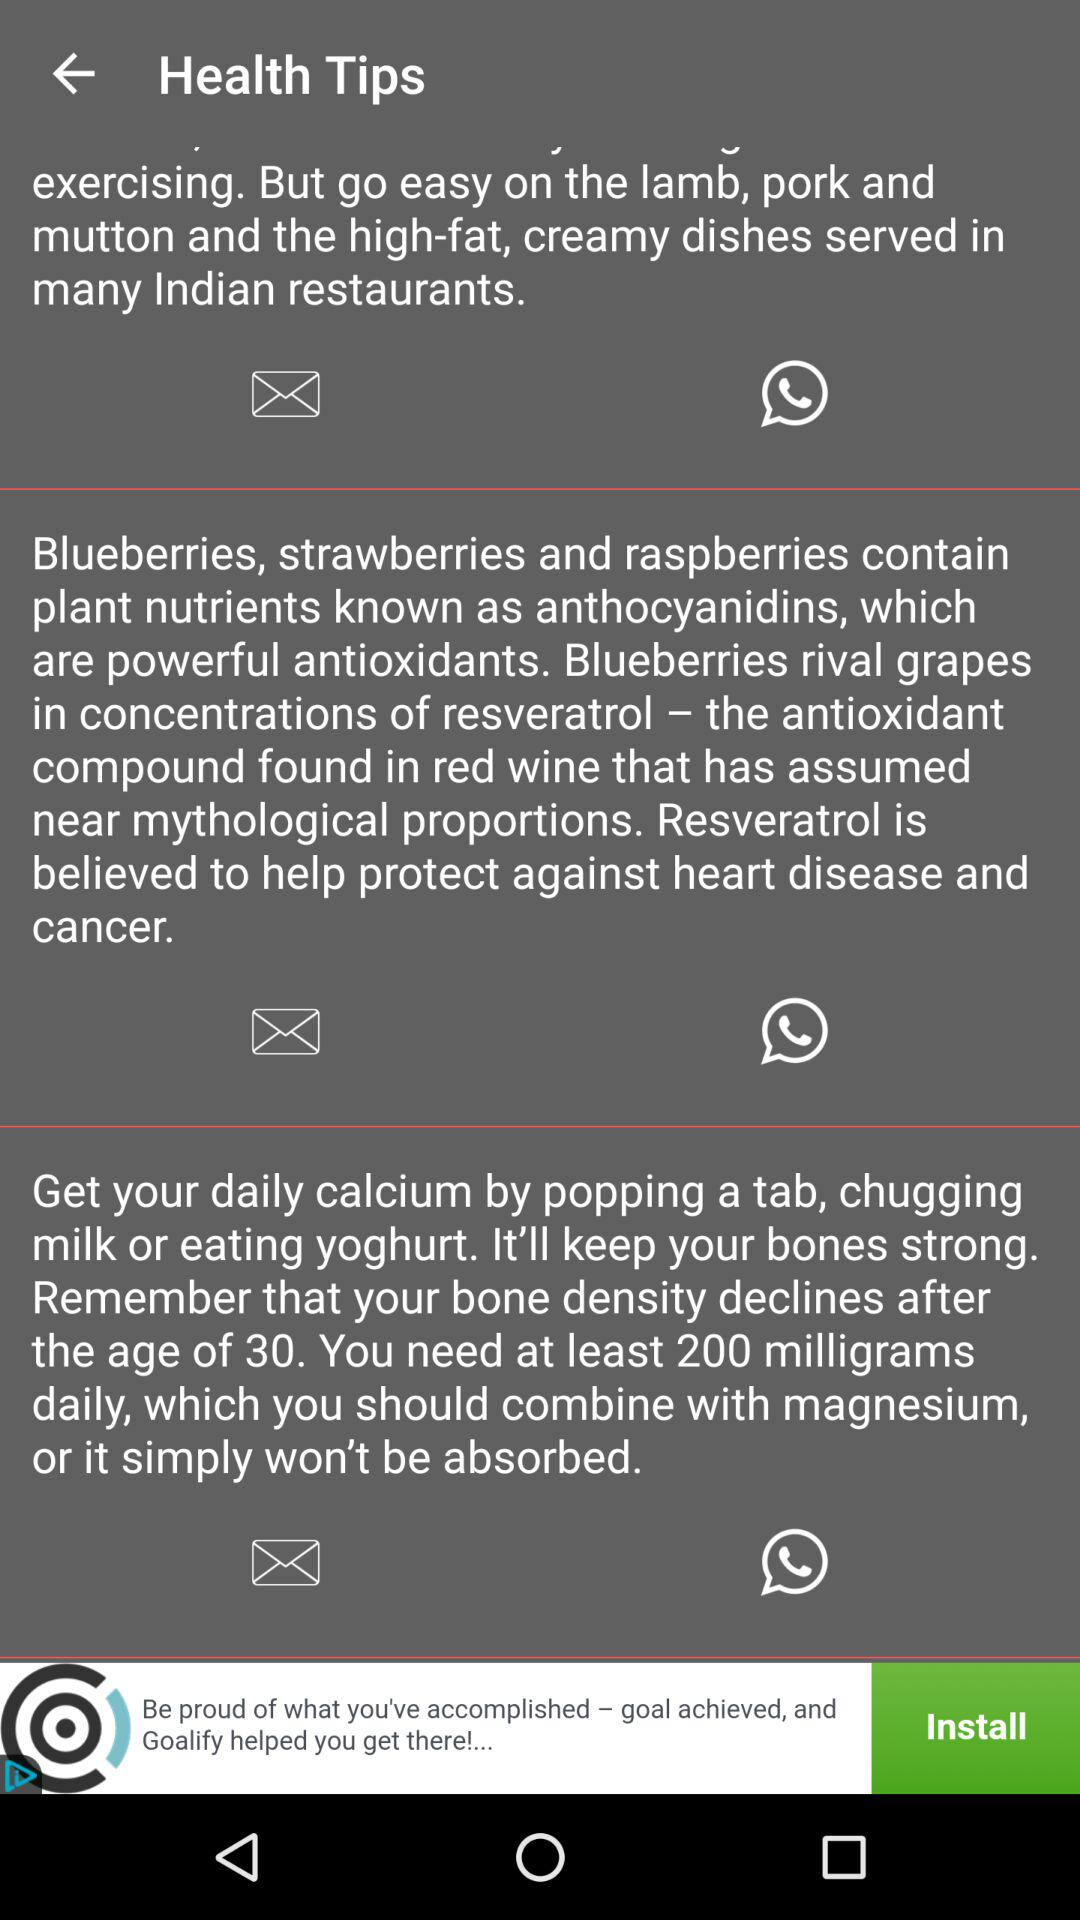How much calcium is needed after the age of 30? After the age of 30, at least 200 milligrams of calcium are needed daily. 